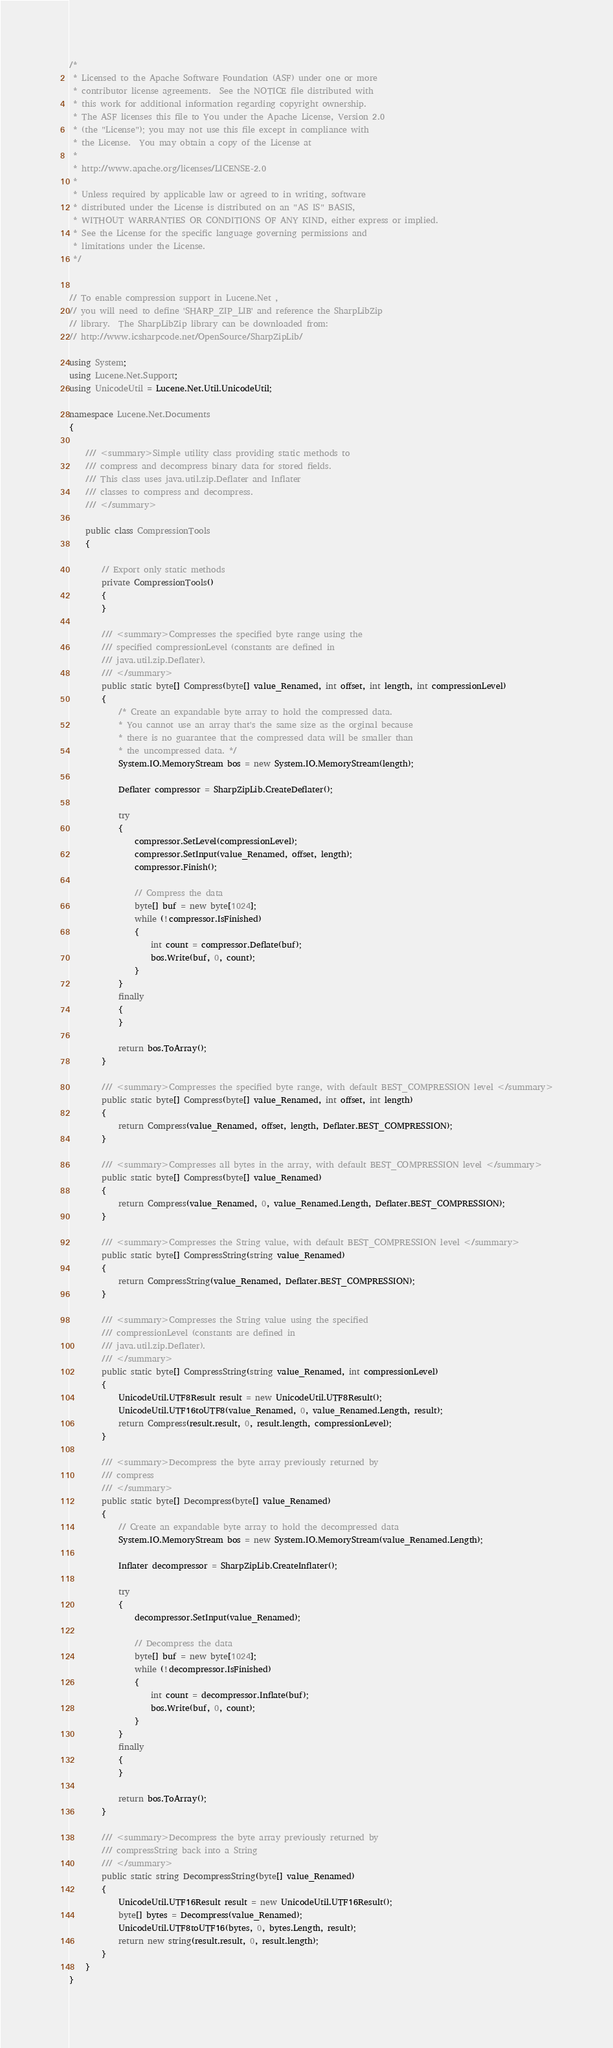Convert code to text. <code><loc_0><loc_0><loc_500><loc_500><_C#_>/* 
 * Licensed to the Apache Software Foundation (ASF) under one or more
 * contributor license agreements.  See the NOTICE file distributed with
 * this work for additional information regarding copyright ownership.
 * The ASF licenses this file to You under the Apache License, Version 2.0
 * (the "License"); you may not use this file except in compliance with
 * the License.  You may obtain a copy of the License at
 * 
 * http://www.apache.org/licenses/LICENSE-2.0
 * 
 * Unless required by applicable law or agreed to in writing, software
 * distributed under the License is distributed on an "AS IS" BASIS,
 * WITHOUT WARRANTIES OR CONDITIONS OF ANY KIND, either express or implied.
 * See the License for the specific language governing permissions and
 * limitations under the License.
 */


// To enable compression support in Lucene.Net ,
// you will need to define 'SHARP_ZIP_LIB' and reference the SharpLibZip 
// library.  The SharpLibZip library can be downloaded from: 
// http://www.icsharpcode.net/OpenSource/SharpZipLib/

using System;
using Lucene.Net.Support;
using UnicodeUtil = Lucene.Net.Util.UnicodeUtil;

namespace Lucene.Net.Documents
{
	
	/// <summary>Simple utility class providing static methods to
	/// compress and decompress binary data for stored fields.
	/// This class uses java.util.zip.Deflater and Inflater
	/// classes to compress and decompress.
	/// </summary>
	
	public class CompressionTools
	{
		
		// Export only static methods
		private CompressionTools()
		{
		}
		
		/// <summary>Compresses the specified byte range using the
		/// specified compressionLevel (constants are defined in
		/// java.util.zip.Deflater). 
		/// </summary>
		public static byte[] Compress(byte[] value_Renamed, int offset, int length, int compressionLevel)
		{
			/* Create an expandable byte array to hold the compressed data.
			* You cannot use an array that's the same size as the orginal because
			* there is no guarantee that the compressed data will be smaller than
			* the uncompressed data. */
			System.IO.MemoryStream bos = new System.IO.MemoryStream(length);

            Deflater compressor = SharpZipLib.CreateDeflater();
			
			try
			{
				compressor.SetLevel(compressionLevel);
				compressor.SetInput(value_Renamed, offset, length);
				compressor.Finish();
				
				// Compress the data
				byte[] buf = new byte[1024];
				while (!compressor.IsFinished)
				{
					int count = compressor.Deflate(buf);
					bos.Write(buf, 0, count);
				}
			}
			finally
			{
			}
			
			return bos.ToArray();
		}
		
		/// <summary>Compresses the specified byte range, with default BEST_COMPRESSION level </summary>
		public static byte[] Compress(byte[] value_Renamed, int offset, int length)
        {
			return Compress(value_Renamed, offset, length, Deflater.BEST_COMPRESSION);
		}
		
		/// <summary>Compresses all bytes in the array, with default BEST_COMPRESSION level </summary>
		public static byte[] Compress(byte[] value_Renamed)
		{
            return Compress(value_Renamed, 0, value_Renamed.Length, Deflater.BEST_COMPRESSION);
		}
		
		/// <summary>Compresses the String value, with default BEST_COMPRESSION level </summary>
		public static byte[] CompressString(string value_Renamed)
		{
            return CompressString(value_Renamed, Deflater.BEST_COMPRESSION);
		}
		
		/// <summary>Compresses the String value using the specified
		/// compressionLevel (constants are defined in
		/// java.util.zip.Deflater). 
		/// </summary>
		public static byte[] CompressString(string value_Renamed, int compressionLevel)
		{
			UnicodeUtil.UTF8Result result = new UnicodeUtil.UTF8Result();
			UnicodeUtil.UTF16toUTF8(value_Renamed, 0, value_Renamed.Length, result);
			return Compress(result.result, 0, result.length, compressionLevel);
		}
		
		/// <summary>Decompress the byte array previously returned by
		/// compress 
		/// </summary>
		public static byte[] Decompress(byte[] value_Renamed)
		{
			// Create an expandable byte array to hold the decompressed data
			System.IO.MemoryStream bos = new System.IO.MemoryStream(value_Renamed.Length);
			
			Inflater decompressor = SharpZipLib.CreateInflater();
			
			try
			{
				decompressor.SetInput(value_Renamed);
				
				// Decompress the data
				byte[] buf = new byte[1024];
				while (!decompressor.IsFinished)
				{
					int count = decompressor.Inflate(buf);
					bos.Write(buf, 0, count);
				}
			}
			finally
			{
			}
			
			return bos.ToArray();
		}
		
		/// <summary>Decompress the byte array previously returned by
		/// compressString back into a String 
		/// </summary>
		public static string DecompressString(byte[] value_Renamed)
		{
			UnicodeUtil.UTF16Result result = new UnicodeUtil.UTF16Result();
			byte[] bytes = Decompress(value_Renamed);
			UnicodeUtil.UTF8toUTF16(bytes, 0, bytes.Length, result);
			return new string(result.result, 0, result.length);
		}
	}
}

</code> 